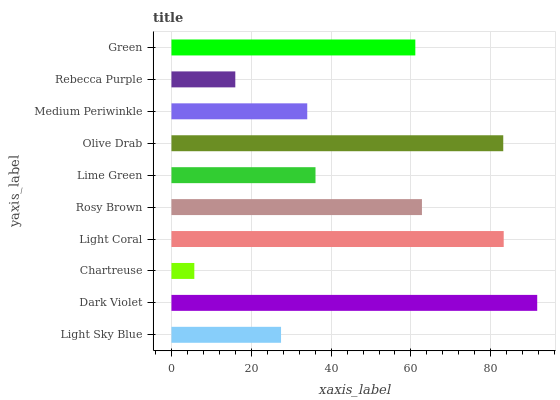Is Chartreuse the minimum?
Answer yes or no. Yes. Is Dark Violet the maximum?
Answer yes or no. Yes. Is Dark Violet the minimum?
Answer yes or no. No. Is Chartreuse the maximum?
Answer yes or no. No. Is Dark Violet greater than Chartreuse?
Answer yes or no. Yes. Is Chartreuse less than Dark Violet?
Answer yes or no. Yes. Is Chartreuse greater than Dark Violet?
Answer yes or no. No. Is Dark Violet less than Chartreuse?
Answer yes or no. No. Is Green the high median?
Answer yes or no. Yes. Is Lime Green the low median?
Answer yes or no. Yes. Is Light Sky Blue the high median?
Answer yes or no. No. Is Dark Violet the low median?
Answer yes or no. No. 